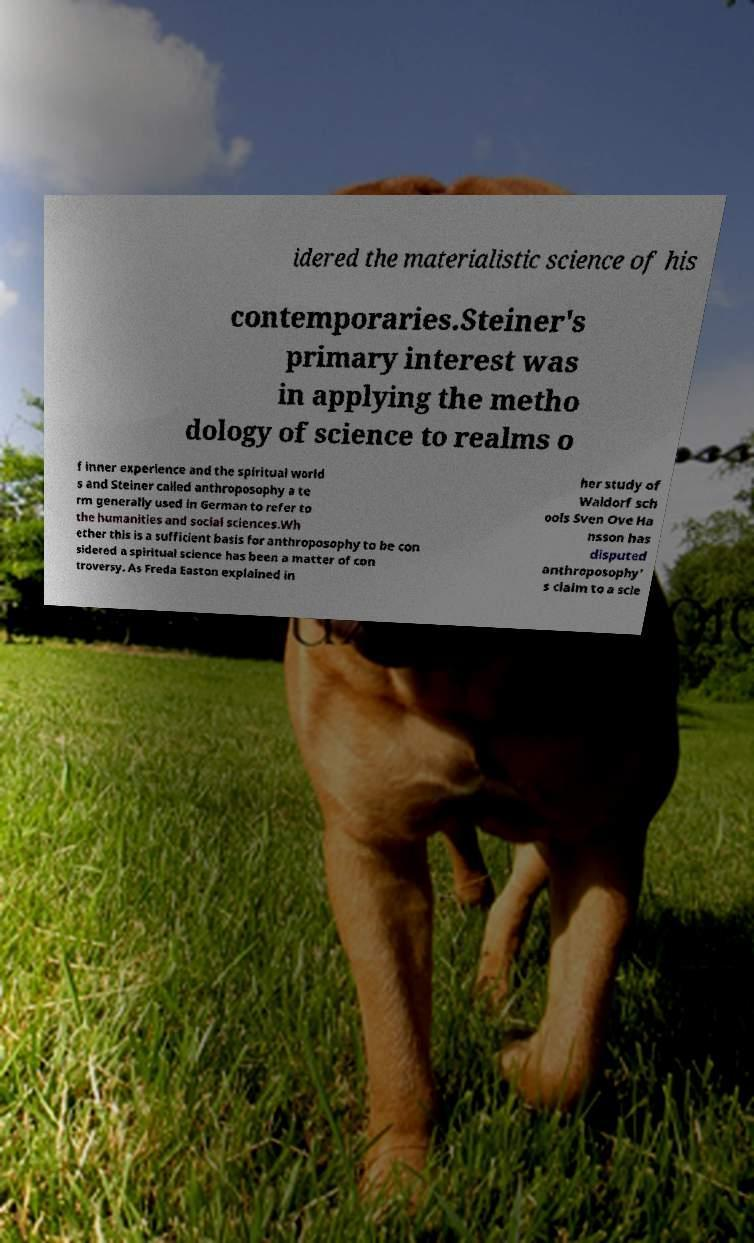Please identify and transcribe the text found in this image. idered the materialistic science of his contemporaries.Steiner's primary interest was in applying the metho dology of science to realms o f inner experience and the spiritual world s and Steiner called anthroposophy a te rm generally used in German to refer to the humanities and social sciences.Wh ether this is a sufficient basis for anthroposophy to be con sidered a spiritual science has been a matter of con troversy. As Freda Easton explained in her study of Waldorf sch ools Sven Ove Ha nsson has disputed anthroposophy' s claim to a scie 